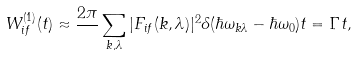<formula> <loc_0><loc_0><loc_500><loc_500>W _ { i f } ^ { ( 1 ) } ( t ) \approx \frac { 2 \pi } { } \sum _ { { k } , \lambda } | F _ { i f } ( { k } , \lambda ) | ^ { 2 } \delta ( \hbar { \omega } _ { { k } \lambda } - \hbar { \omega } _ { 0 } ) t = \Gamma t ,</formula> 